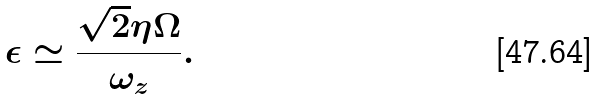<formula> <loc_0><loc_0><loc_500><loc_500>\epsilon \simeq \frac { \sqrt { 2 } \eta \Omega } { \omega _ { z } } .</formula> 